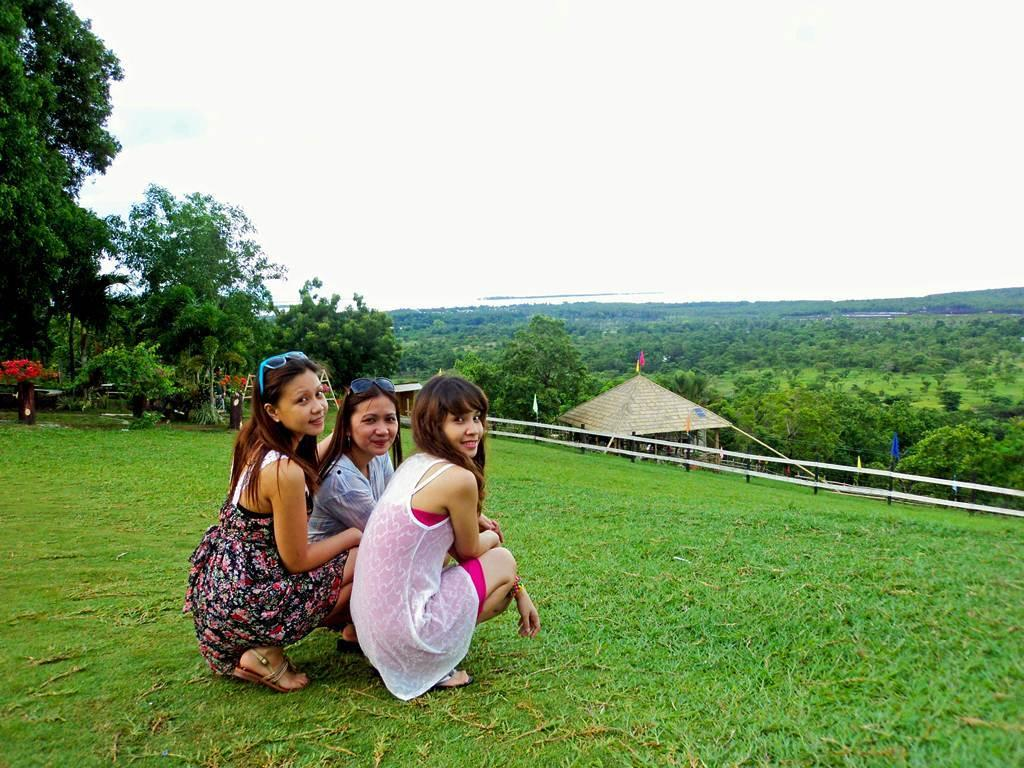What is the primary vegetation covering the land in the image? The land is covered with grass. What are the three people in the image doing? The three people are in a squat position. What can be seen in the background of the image? There are trees and a hut in the background. What type of barrier is present in the image? There is a fence in the image. How does the grass blow in the wind in the image? The grass does not blow in the wind in the image; there is no wind depicted. What type of slip is visible on the people's feet in the image? There is no slip visible on the people's feet in the image; they are in a squat position on the grass. 